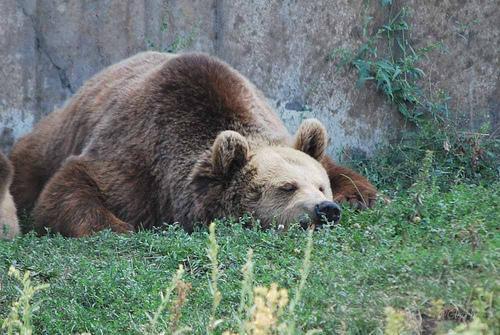How many bears are there?
Give a very brief answer. 1. 